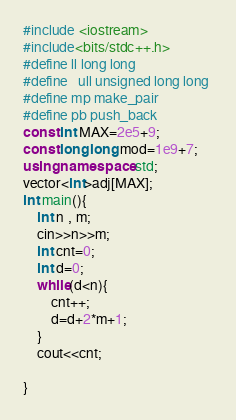Convert code to text. <code><loc_0><loc_0><loc_500><loc_500><_C++_>#include <iostream>
#include<bits/stdc++.h>
#define ll long long
#define   ull unsigned long long 
#define mp make_pair
#define pb push_back
const int MAX=2e5+9;
const long long mod=1e9+7;
using namespace std;
vector<int>adj[MAX];
int main(){
	int n , m;
	cin>>n>>m;
	int cnt=0;
	int d=0;
	while(d<n){
		cnt++;
		d=d+2*m+1;
	}
	cout<<cnt;

}</code> 